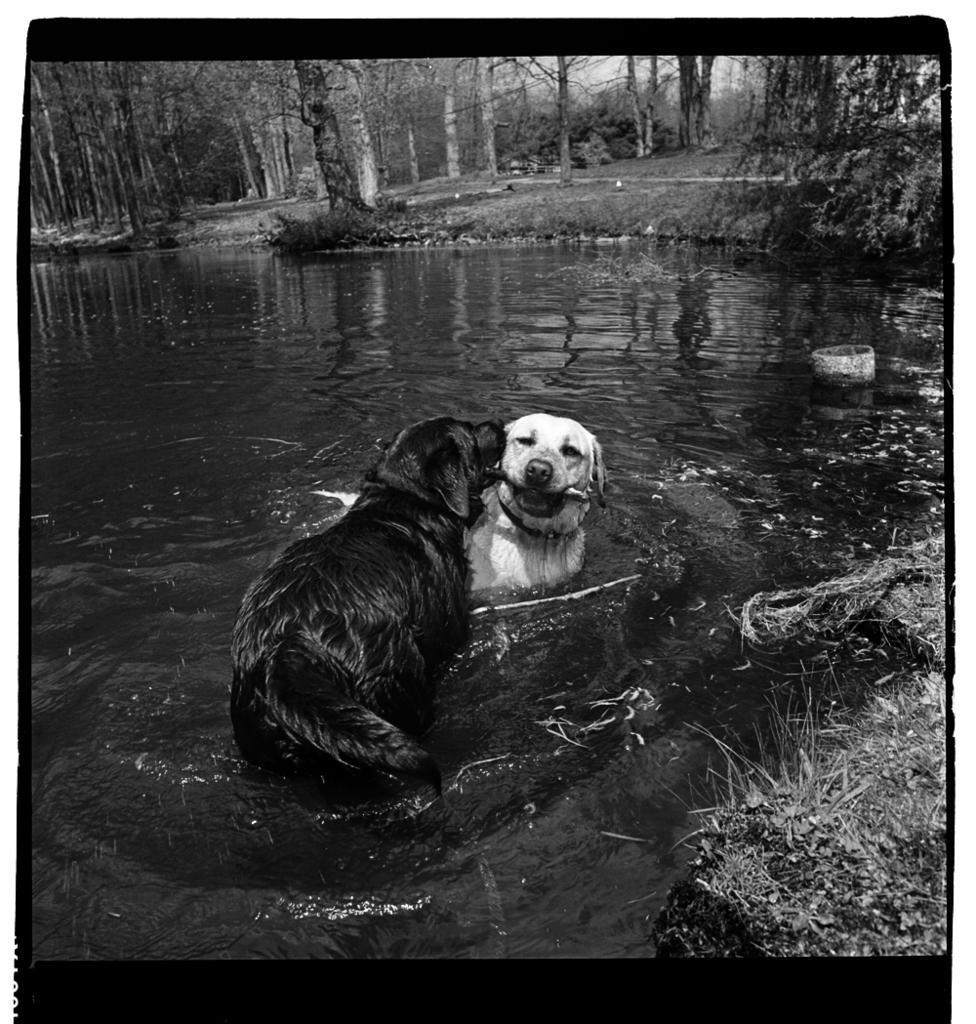What is the color scheme of the image? The image is black and white. How many dogs are present in the image? There are two dogs in the image. What are the dogs doing in the image? The dogs are playing in the water. What can be seen in the background of the image? There are trees in the background of the image. What type of crayon can be seen in the image? There is no crayon present in the image. What kind of respect is being shown between the dogs in the image? The image does not depict any specific interaction between the dogs that would indicate respect. 